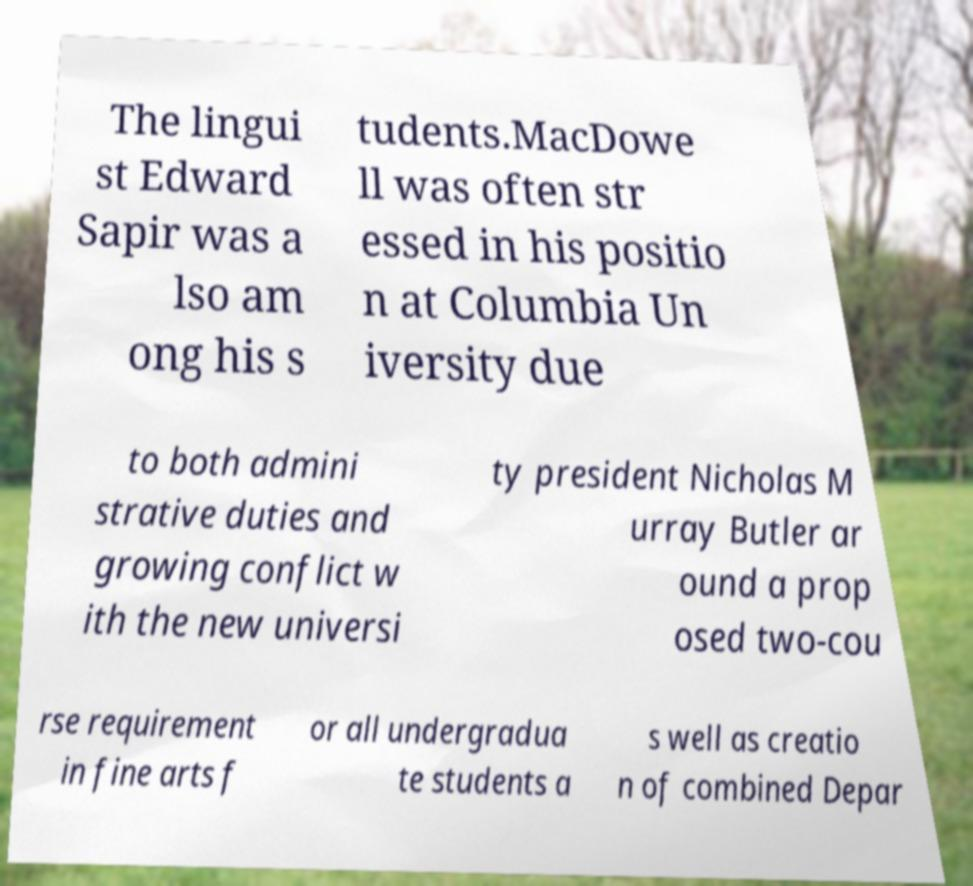For documentation purposes, I need the text within this image transcribed. Could you provide that? The lingui st Edward Sapir was a lso am ong his s tudents.MacDowe ll was often str essed in his positio n at Columbia Un iversity due to both admini strative duties and growing conflict w ith the new universi ty president Nicholas M urray Butler ar ound a prop osed two-cou rse requirement in fine arts f or all undergradua te students a s well as creatio n of combined Depar 